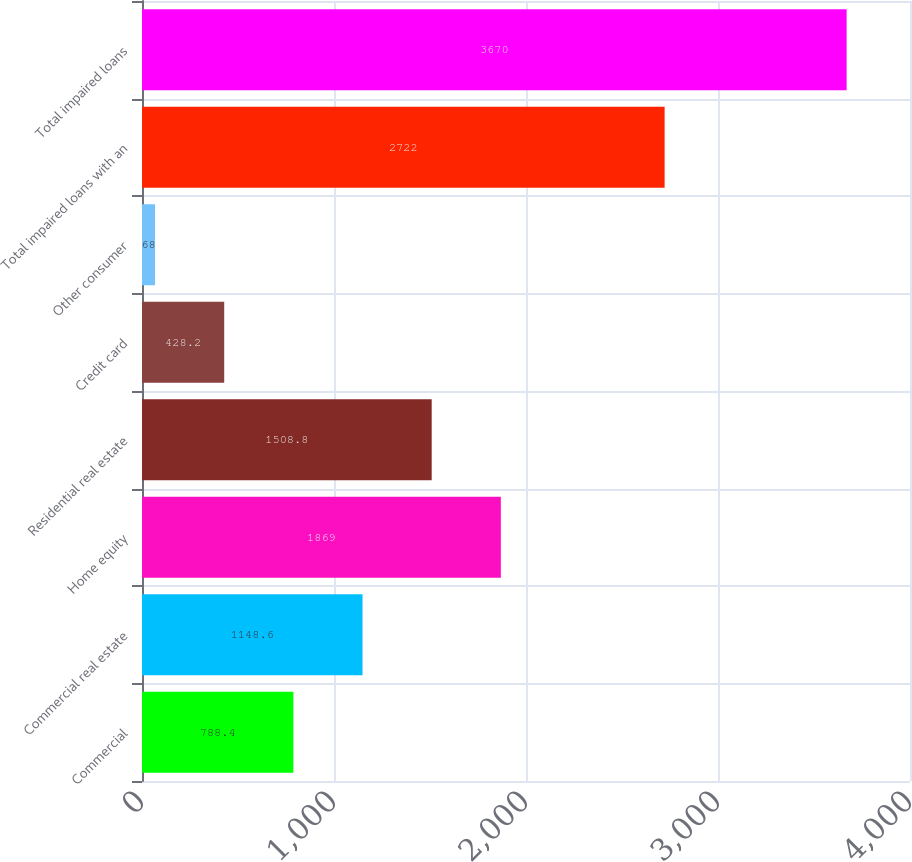Convert chart. <chart><loc_0><loc_0><loc_500><loc_500><bar_chart><fcel>Commercial<fcel>Commercial real estate<fcel>Home equity<fcel>Residential real estate<fcel>Credit card<fcel>Other consumer<fcel>Total impaired loans with an<fcel>Total impaired loans<nl><fcel>788.4<fcel>1148.6<fcel>1869<fcel>1508.8<fcel>428.2<fcel>68<fcel>2722<fcel>3670<nl></chart> 